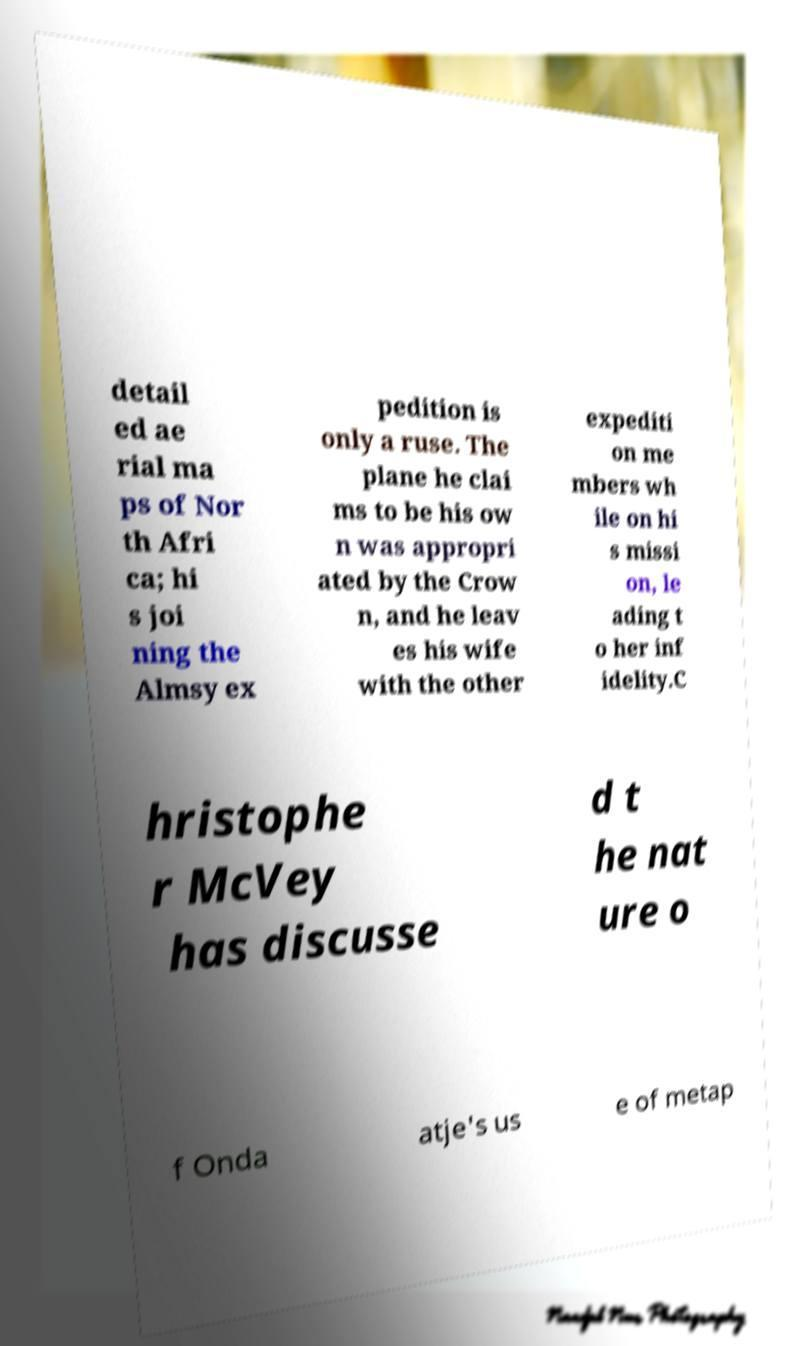Can you read and provide the text displayed in the image?This photo seems to have some interesting text. Can you extract and type it out for me? detail ed ae rial ma ps of Nor th Afri ca; hi s joi ning the Almsy ex pedition is only a ruse. The plane he clai ms to be his ow n was appropri ated by the Crow n, and he leav es his wife with the other expediti on me mbers wh ile on hi s missi on, le ading t o her inf idelity.C hristophe r McVey has discusse d t he nat ure o f Onda atje's us e of metap 